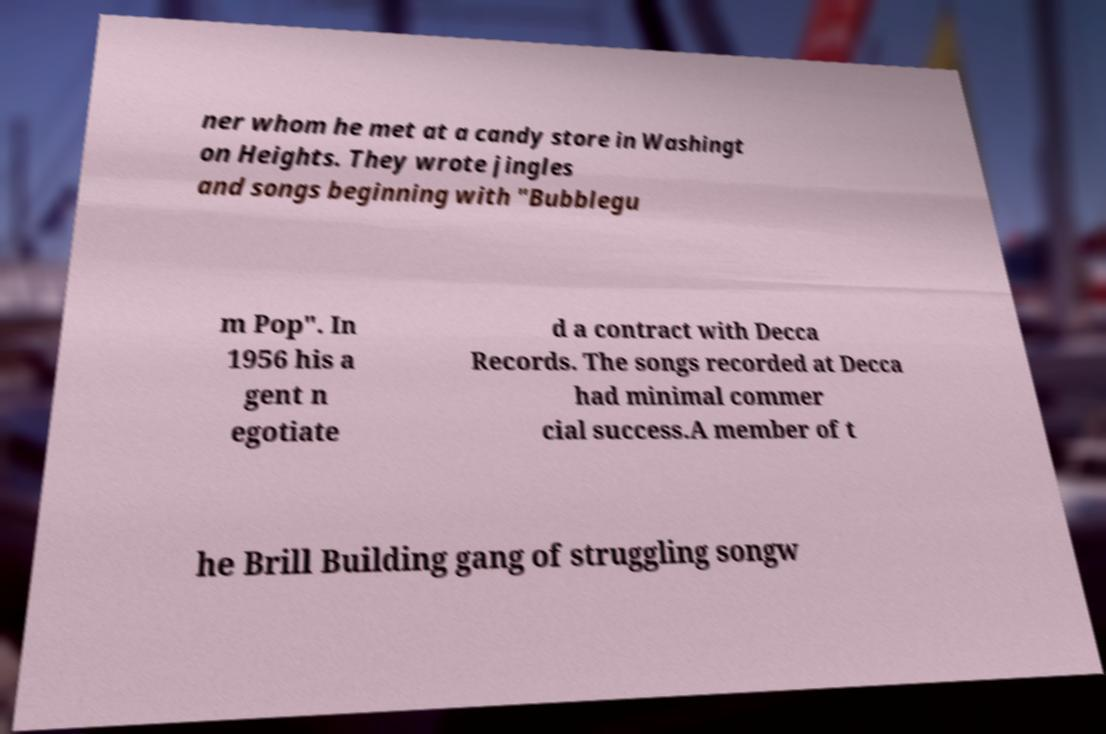For documentation purposes, I need the text within this image transcribed. Could you provide that? ner whom he met at a candy store in Washingt on Heights. They wrote jingles and songs beginning with "Bubblegu m Pop". In 1956 his a gent n egotiate d a contract with Decca Records. The songs recorded at Decca had minimal commer cial success.A member of t he Brill Building gang of struggling songw 